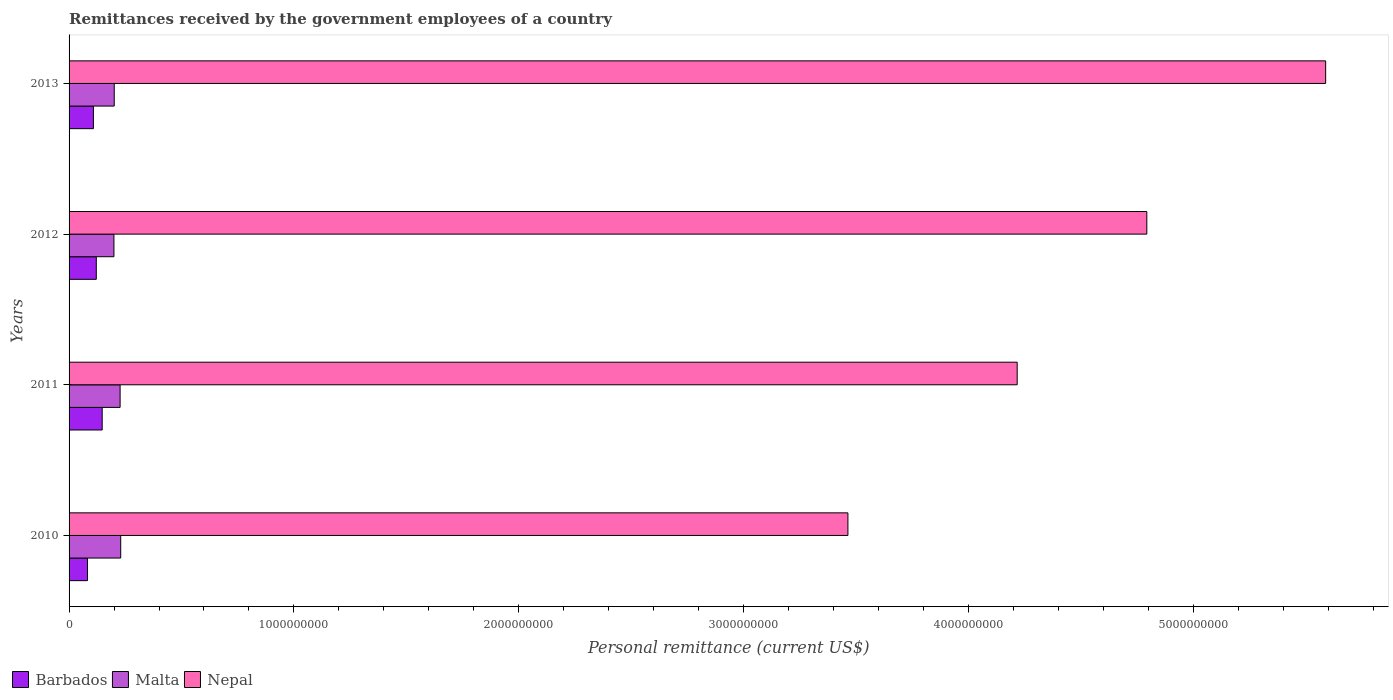How many different coloured bars are there?
Your answer should be very brief. 3. How many groups of bars are there?
Give a very brief answer. 4. Are the number of bars per tick equal to the number of legend labels?
Your response must be concise. Yes. How many bars are there on the 1st tick from the bottom?
Your answer should be very brief. 3. In how many cases, is the number of bars for a given year not equal to the number of legend labels?
Offer a very short reply. 0. What is the remittances received by the government employees in Nepal in 2010?
Make the answer very short. 3.46e+09. Across all years, what is the maximum remittances received by the government employees in Malta?
Your answer should be compact. 2.30e+08. Across all years, what is the minimum remittances received by the government employees in Malta?
Provide a succinct answer. 2.00e+08. What is the total remittances received by the government employees in Barbados in the graph?
Keep it short and to the point. 4.59e+08. What is the difference between the remittances received by the government employees in Barbados in 2012 and that in 2013?
Your answer should be compact. 1.28e+07. What is the difference between the remittances received by the government employees in Barbados in 2010 and the remittances received by the government employees in Nepal in 2013?
Provide a succinct answer. -5.51e+09. What is the average remittances received by the government employees in Barbados per year?
Ensure brevity in your answer.  1.15e+08. In the year 2010, what is the difference between the remittances received by the government employees in Malta and remittances received by the government employees in Barbados?
Offer a very short reply. 1.48e+08. In how many years, is the remittances received by the government employees in Nepal greater than 200000000 US$?
Your answer should be compact. 4. What is the ratio of the remittances received by the government employees in Malta in 2012 to that in 2013?
Offer a very short reply. 0.99. Is the remittances received by the government employees in Malta in 2010 less than that in 2013?
Ensure brevity in your answer.  No. Is the difference between the remittances received by the government employees in Malta in 2011 and 2013 greater than the difference between the remittances received by the government employees in Barbados in 2011 and 2013?
Offer a terse response. No. What is the difference between the highest and the second highest remittances received by the government employees in Nepal?
Provide a succinct answer. 7.95e+08. What is the difference between the highest and the lowest remittances received by the government employees in Malta?
Make the answer very short. 3.01e+07. In how many years, is the remittances received by the government employees in Barbados greater than the average remittances received by the government employees in Barbados taken over all years?
Your answer should be compact. 2. Is the sum of the remittances received by the government employees in Nepal in 2012 and 2013 greater than the maximum remittances received by the government employees in Malta across all years?
Make the answer very short. Yes. What does the 2nd bar from the top in 2010 represents?
Your answer should be very brief. Malta. What does the 2nd bar from the bottom in 2010 represents?
Your answer should be compact. Malta. Is it the case that in every year, the sum of the remittances received by the government employees in Nepal and remittances received by the government employees in Malta is greater than the remittances received by the government employees in Barbados?
Offer a very short reply. Yes. How many bars are there?
Ensure brevity in your answer.  12. What is the difference between two consecutive major ticks on the X-axis?
Offer a very short reply. 1.00e+09. Does the graph contain grids?
Offer a very short reply. No. Where does the legend appear in the graph?
Your answer should be very brief. Bottom left. What is the title of the graph?
Offer a terse response. Remittances received by the government employees of a country. Does "Canada" appear as one of the legend labels in the graph?
Make the answer very short. No. What is the label or title of the X-axis?
Your response must be concise. Personal remittance (current US$). What is the Personal remittance (current US$) in Barbados in 2010?
Provide a succinct answer. 8.19e+07. What is the Personal remittance (current US$) of Malta in 2010?
Ensure brevity in your answer.  2.30e+08. What is the Personal remittance (current US$) in Nepal in 2010?
Give a very brief answer. 3.46e+09. What is the Personal remittance (current US$) of Barbados in 2011?
Keep it short and to the point. 1.47e+08. What is the Personal remittance (current US$) in Malta in 2011?
Provide a short and direct response. 2.27e+08. What is the Personal remittance (current US$) in Nepal in 2011?
Give a very brief answer. 4.22e+09. What is the Personal remittance (current US$) of Barbados in 2012?
Offer a very short reply. 1.21e+08. What is the Personal remittance (current US$) of Malta in 2012?
Give a very brief answer. 2.00e+08. What is the Personal remittance (current US$) in Nepal in 2012?
Your response must be concise. 4.79e+09. What is the Personal remittance (current US$) of Barbados in 2013?
Provide a succinct answer. 1.08e+08. What is the Personal remittance (current US$) in Malta in 2013?
Your answer should be compact. 2.01e+08. What is the Personal remittance (current US$) in Nepal in 2013?
Keep it short and to the point. 5.59e+09. Across all years, what is the maximum Personal remittance (current US$) in Barbados?
Your answer should be very brief. 1.47e+08. Across all years, what is the maximum Personal remittance (current US$) of Malta?
Your answer should be very brief. 2.30e+08. Across all years, what is the maximum Personal remittance (current US$) of Nepal?
Ensure brevity in your answer.  5.59e+09. Across all years, what is the minimum Personal remittance (current US$) in Barbados?
Your answer should be compact. 8.19e+07. Across all years, what is the minimum Personal remittance (current US$) of Malta?
Your answer should be compact. 2.00e+08. Across all years, what is the minimum Personal remittance (current US$) of Nepal?
Keep it short and to the point. 3.46e+09. What is the total Personal remittance (current US$) in Barbados in the graph?
Give a very brief answer. 4.59e+08. What is the total Personal remittance (current US$) in Malta in the graph?
Give a very brief answer. 8.57e+08. What is the total Personal remittance (current US$) of Nepal in the graph?
Provide a short and direct response. 1.81e+1. What is the difference between the Personal remittance (current US$) in Barbados in 2010 and that in 2011?
Make the answer very short. -6.54e+07. What is the difference between the Personal remittance (current US$) in Malta in 2010 and that in 2011?
Provide a short and direct response. 2.65e+06. What is the difference between the Personal remittance (current US$) of Nepal in 2010 and that in 2011?
Your answer should be compact. -7.53e+08. What is the difference between the Personal remittance (current US$) in Barbados in 2010 and that in 2012?
Your answer should be compact. -3.92e+07. What is the difference between the Personal remittance (current US$) of Malta in 2010 and that in 2012?
Provide a succinct answer. 3.01e+07. What is the difference between the Personal remittance (current US$) of Nepal in 2010 and that in 2012?
Offer a very short reply. -1.33e+09. What is the difference between the Personal remittance (current US$) in Barbados in 2010 and that in 2013?
Your answer should be compact. -2.64e+07. What is the difference between the Personal remittance (current US$) in Malta in 2010 and that in 2013?
Keep it short and to the point. 2.88e+07. What is the difference between the Personal remittance (current US$) in Nepal in 2010 and that in 2013?
Make the answer very short. -2.12e+09. What is the difference between the Personal remittance (current US$) in Barbados in 2011 and that in 2012?
Your response must be concise. 2.62e+07. What is the difference between the Personal remittance (current US$) in Malta in 2011 and that in 2012?
Give a very brief answer. 2.74e+07. What is the difference between the Personal remittance (current US$) in Nepal in 2011 and that in 2012?
Your answer should be compact. -5.77e+08. What is the difference between the Personal remittance (current US$) of Barbados in 2011 and that in 2013?
Give a very brief answer. 3.90e+07. What is the difference between the Personal remittance (current US$) in Malta in 2011 and that in 2013?
Make the answer very short. 2.61e+07. What is the difference between the Personal remittance (current US$) in Nepal in 2011 and that in 2013?
Keep it short and to the point. -1.37e+09. What is the difference between the Personal remittance (current US$) in Barbados in 2012 and that in 2013?
Provide a short and direct response. 1.28e+07. What is the difference between the Personal remittance (current US$) in Malta in 2012 and that in 2013?
Your answer should be very brief. -1.31e+06. What is the difference between the Personal remittance (current US$) in Nepal in 2012 and that in 2013?
Provide a short and direct response. -7.95e+08. What is the difference between the Personal remittance (current US$) in Barbados in 2010 and the Personal remittance (current US$) in Malta in 2011?
Offer a very short reply. -1.45e+08. What is the difference between the Personal remittance (current US$) of Barbados in 2010 and the Personal remittance (current US$) of Nepal in 2011?
Make the answer very short. -4.14e+09. What is the difference between the Personal remittance (current US$) in Malta in 2010 and the Personal remittance (current US$) in Nepal in 2011?
Make the answer very short. -3.99e+09. What is the difference between the Personal remittance (current US$) in Barbados in 2010 and the Personal remittance (current US$) in Malta in 2012?
Your response must be concise. -1.18e+08. What is the difference between the Personal remittance (current US$) in Barbados in 2010 and the Personal remittance (current US$) in Nepal in 2012?
Ensure brevity in your answer.  -4.71e+09. What is the difference between the Personal remittance (current US$) of Malta in 2010 and the Personal remittance (current US$) of Nepal in 2012?
Offer a terse response. -4.56e+09. What is the difference between the Personal remittance (current US$) in Barbados in 2010 and the Personal remittance (current US$) in Malta in 2013?
Provide a succinct answer. -1.19e+08. What is the difference between the Personal remittance (current US$) of Barbados in 2010 and the Personal remittance (current US$) of Nepal in 2013?
Make the answer very short. -5.51e+09. What is the difference between the Personal remittance (current US$) of Malta in 2010 and the Personal remittance (current US$) of Nepal in 2013?
Provide a succinct answer. -5.36e+09. What is the difference between the Personal remittance (current US$) in Barbados in 2011 and the Personal remittance (current US$) in Malta in 2012?
Your answer should be very brief. -5.23e+07. What is the difference between the Personal remittance (current US$) of Barbados in 2011 and the Personal remittance (current US$) of Nepal in 2012?
Your answer should be very brief. -4.65e+09. What is the difference between the Personal remittance (current US$) in Malta in 2011 and the Personal remittance (current US$) in Nepal in 2012?
Offer a very short reply. -4.57e+09. What is the difference between the Personal remittance (current US$) of Barbados in 2011 and the Personal remittance (current US$) of Malta in 2013?
Your answer should be very brief. -5.36e+07. What is the difference between the Personal remittance (current US$) of Barbados in 2011 and the Personal remittance (current US$) of Nepal in 2013?
Your answer should be compact. -5.44e+09. What is the difference between the Personal remittance (current US$) of Malta in 2011 and the Personal remittance (current US$) of Nepal in 2013?
Make the answer very short. -5.36e+09. What is the difference between the Personal remittance (current US$) in Barbados in 2012 and the Personal remittance (current US$) in Malta in 2013?
Keep it short and to the point. -7.98e+07. What is the difference between the Personal remittance (current US$) in Barbados in 2012 and the Personal remittance (current US$) in Nepal in 2013?
Your answer should be very brief. -5.47e+09. What is the difference between the Personal remittance (current US$) in Malta in 2012 and the Personal remittance (current US$) in Nepal in 2013?
Provide a succinct answer. -5.39e+09. What is the average Personal remittance (current US$) of Barbados per year?
Offer a very short reply. 1.15e+08. What is the average Personal remittance (current US$) of Malta per year?
Give a very brief answer. 2.14e+08. What is the average Personal remittance (current US$) of Nepal per year?
Offer a terse response. 4.52e+09. In the year 2010, what is the difference between the Personal remittance (current US$) in Barbados and Personal remittance (current US$) in Malta?
Ensure brevity in your answer.  -1.48e+08. In the year 2010, what is the difference between the Personal remittance (current US$) in Barbados and Personal remittance (current US$) in Nepal?
Your answer should be very brief. -3.38e+09. In the year 2010, what is the difference between the Personal remittance (current US$) in Malta and Personal remittance (current US$) in Nepal?
Provide a succinct answer. -3.23e+09. In the year 2011, what is the difference between the Personal remittance (current US$) of Barbados and Personal remittance (current US$) of Malta?
Your response must be concise. -7.97e+07. In the year 2011, what is the difference between the Personal remittance (current US$) in Barbados and Personal remittance (current US$) in Nepal?
Make the answer very short. -4.07e+09. In the year 2011, what is the difference between the Personal remittance (current US$) of Malta and Personal remittance (current US$) of Nepal?
Give a very brief answer. -3.99e+09. In the year 2012, what is the difference between the Personal remittance (current US$) in Barbados and Personal remittance (current US$) in Malta?
Give a very brief answer. -7.85e+07. In the year 2012, what is the difference between the Personal remittance (current US$) in Barbados and Personal remittance (current US$) in Nepal?
Your answer should be very brief. -4.67e+09. In the year 2012, what is the difference between the Personal remittance (current US$) in Malta and Personal remittance (current US$) in Nepal?
Give a very brief answer. -4.59e+09. In the year 2013, what is the difference between the Personal remittance (current US$) of Barbados and Personal remittance (current US$) of Malta?
Keep it short and to the point. -9.26e+07. In the year 2013, what is the difference between the Personal remittance (current US$) in Barbados and Personal remittance (current US$) in Nepal?
Provide a short and direct response. -5.48e+09. In the year 2013, what is the difference between the Personal remittance (current US$) in Malta and Personal remittance (current US$) in Nepal?
Your answer should be compact. -5.39e+09. What is the ratio of the Personal remittance (current US$) in Barbados in 2010 to that in 2011?
Give a very brief answer. 0.56. What is the ratio of the Personal remittance (current US$) in Malta in 2010 to that in 2011?
Keep it short and to the point. 1.01. What is the ratio of the Personal remittance (current US$) of Nepal in 2010 to that in 2011?
Make the answer very short. 0.82. What is the ratio of the Personal remittance (current US$) in Barbados in 2010 to that in 2012?
Provide a short and direct response. 0.68. What is the ratio of the Personal remittance (current US$) of Malta in 2010 to that in 2012?
Keep it short and to the point. 1.15. What is the ratio of the Personal remittance (current US$) of Nepal in 2010 to that in 2012?
Offer a very short reply. 0.72. What is the ratio of the Personal remittance (current US$) of Barbados in 2010 to that in 2013?
Give a very brief answer. 0.76. What is the ratio of the Personal remittance (current US$) of Malta in 2010 to that in 2013?
Your answer should be compact. 1.14. What is the ratio of the Personal remittance (current US$) of Nepal in 2010 to that in 2013?
Keep it short and to the point. 0.62. What is the ratio of the Personal remittance (current US$) in Barbados in 2011 to that in 2012?
Offer a very short reply. 1.22. What is the ratio of the Personal remittance (current US$) of Malta in 2011 to that in 2012?
Keep it short and to the point. 1.14. What is the ratio of the Personal remittance (current US$) of Nepal in 2011 to that in 2012?
Provide a succinct answer. 0.88. What is the ratio of the Personal remittance (current US$) of Barbados in 2011 to that in 2013?
Make the answer very short. 1.36. What is the ratio of the Personal remittance (current US$) of Malta in 2011 to that in 2013?
Offer a terse response. 1.13. What is the ratio of the Personal remittance (current US$) of Nepal in 2011 to that in 2013?
Keep it short and to the point. 0.75. What is the ratio of the Personal remittance (current US$) of Barbados in 2012 to that in 2013?
Provide a succinct answer. 1.12. What is the ratio of the Personal remittance (current US$) in Nepal in 2012 to that in 2013?
Keep it short and to the point. 0.86. What is the difference between the highest and the second highest Personal remittance (current US$) in Barbados?
Offer a very short reply. 2.62e+07. What is the difference between the highest and the second highest Personal remittance (current US$) of Malta?
Provide a succinct answer. 2.65e+06. What is the difference between the highest and the second highest Personal remittance (current US$) of Nepal?
Provide a succinct answer. 7.95e+08. What is the difference between the highest and the lowest Personal remittance (current US$) in Barbados?
Provide a succinct answer. 6.54e+07. What is the difference between the highest and the lowest Personal remittance (current US$) in Malta?
Give a very brief answer. 3.01e+07. What is the difference between the highest and the lowest Personal remittance (current US$) in Nepal?
Your answer should be compact. 2.12e+09. 